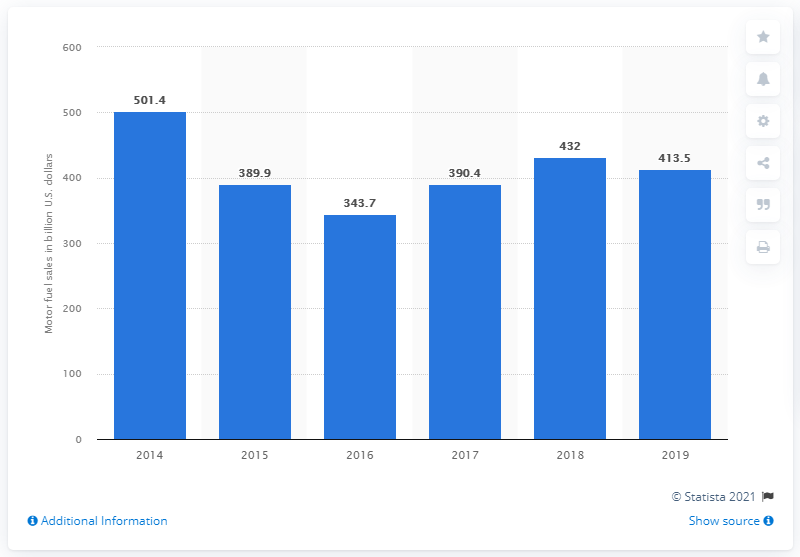Outline some significant characteristics in this image. In 2019, the total sales of motor fuel in convenience stores amounted to 413.5 dollars. In 2014, the sales of motor fuel in the United States totaled 501.4 billion gallons. 